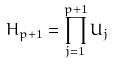<formula> <loc_0><loc_0><loc_500><loc_500>H _ { p + 1 } = \prod _ { j = 1 } ^ { p + 1 } U _ { j }</formula> 